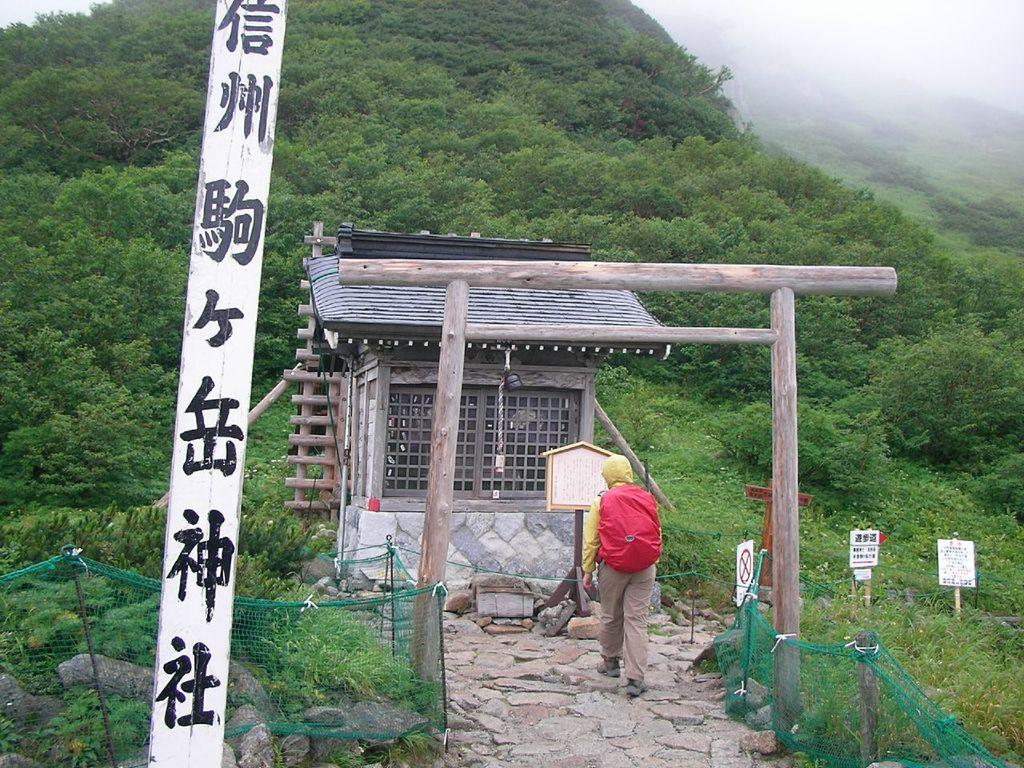What is the main subject of the image? There is a person in the image. What is the person carrying? The person is carrying a red backpack. What is the person doing in the image? The person is walking on the ground. What can be seen in the background of the image? There are trees and fog in the background of the image. What other structures are present in the image? There is a fence, boards, and a house in the image. What type of cough medicine is the person taking in the image? There is no indication in the image that the person is taking any cough medicine, and therefore it cannot be determined from the picture. 